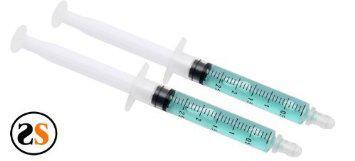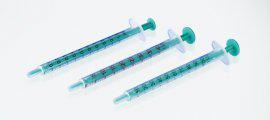The first image is the image on the left, the second image is the image on the right. For the images displayed, is the sentence "An image features exactly one syringe with an exposed needle tip." factually correct? Answer yes or no. No. The first image is the image on the left, the second image is the image on the right. Evaluate the accuracy of this statement regarding the images: "There are four or more syringes in total.". Is it true? Answer yes or no. Yes. 